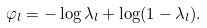Convert formula to latex. <formula><loc_0><loc_0><loc_500><loc_500>\varphi _ { l } = - \log \lambda _ { l } + \log ( 1 - \lambda _ { l } ) .</formula> 